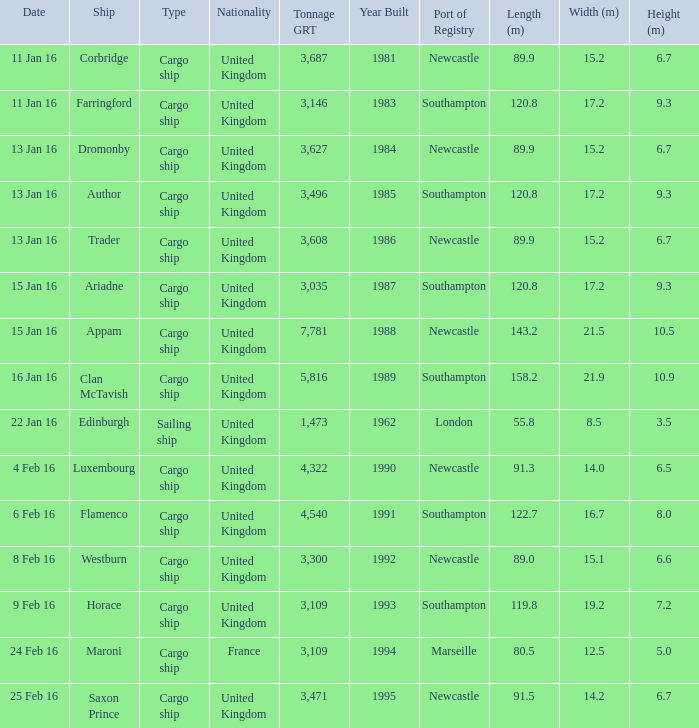Can you give me this table as a dict? {'header': ['Date', 'Ship', 'Type', 'Nationality', 'Tonnage GRT', 'Year Built', 'Port of Registry', 'Length (m)', 'Width (m)', 'Height (m)'], 'rows': [['11 Jan 16', 'Corbridge', 'Cargo ship', 'United Kingdom', '3,687', '1981', 'Newcastle', '89.9', '15.2', '6.7'], ['11 Jan 16', 'Farringford', 'Cargo ship', 'United Kingdom', '3,146', '1983', 'Southampton', '120.8', '17.2', '9.3'], ['13 Jan 16', 'Dromonby', 'Cargo ship', 'United Kingdom', '3,627', '1984', 'Newcastle', '89.9', '15.2', '6.7'], ['13 Jan 16', 'Author', 'Cargo ship', 'United Kingdom', '3,496', '1985', 'Southampton', '120.8', '17.2', '9.3'], ['13 Jan 16', 'Trader', 'Cargo ship', 'United Kingdom', '3,608', '1986', 'Newcastle', '89.9', '15.2', '6.7'], ['15 Jan 16', 'Ariadne', 'Cargo ship', 'United Kingdom', '3,035', '1987', 'Southampton', '120.8', '17.2', '9.3'], ['15 Jan 16', 'Appam', 'Cargo ship', 'United Kingdom', '7,781', '1988', 'Newcastle', '143.2', '21.5', '10.5'], ['16 Jan 16', 'Clan McTavish', 'Cargo ship', 'United Kingdom', '5,816', '1989', 'Southampton', '158.2', '21.9', '10.9'], ['22 Jan 16', 'Edinburgh', 'Sailing ship', 'United Kingdom', '1,473', '1962', 'London', '55.8', '8.5', '3.5'], ['4 Feb 16', 'Luxembourg', 'Cargo ship', 'United Kingdom', '4,322', '1990', 'Newcastle', '91.3', '14.0', '6.5'], ['6 Feb 16', 'Flamenco', 'Cargo ship', 'United Kingdom', '4,540', '1991', 'Southampton', '122.7', '16.7', '8.0'], ['8 Feb 16', 'Westburn', 'Cargo ship', 'United Kingdom', '3,300', '1992', 'Newcastle', '89.0', '15.1', '6.6'], ['9 Feb 16', 'Horace', 'Cargo ship', 'United Kingdom', '3,109', '1993', 'Southampton', '119.8', '19.2', '7.2'], ['24 Feb 16', 'Maroni', 'Cargo ship', 'France', '3,109', '1994', 'Marseille', '80.5', '12.5', '5.0'], ['25 Feb 16', 'Saxon Prince', 'Cargo ship', 'United Kingdom', '3,471', '1995', 'Newcastle', '91.5', '14.2', '6.7']]} What is the total tonnage grt of the cargo ship(s) sunk or captured on 4 feb 16? 1.0. 